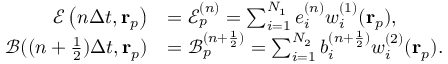Convert formula to latex. <formula><loc_0><loc_0><loc_500><loc_500>\begin{array} { r l } { \mathcal { E } \left ( n \Delta t , r _ { p } \right ) } & { = \mathcal { E } _ { p } ^ { ( n ) } = \sum _ { i = 1 } ^ { N _ { 1 } } e _ { i } ^ { ( n ) } w _ { i } ^ { ( 1 ) } ( r _ { p } ) , } \\ { \mathcal { B } ( ( n + \frac { 1 } { 2 } ) \Delta t , r _ { p } ) } & { = \mathcal { B } _ { p } ^ { ( n + \frac { 1 } { 2 } ) } = \sum _ { i = 1 } ^ { N _ { 2 } } b _ { i } ^ { ( n + \frac { 1 } { 2 } ) } w _ { i } ^ { ( 2 ) } ( r _ { p } ) . } \end{array}</formula> 